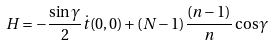Convert formula to latex. <formula><loc_0><loc_0><loc_500><loc_500>H = - \frac { \sin \gamma } { 2 } \dot { t } ( 0 , 0 ) + ( N - 1 ) \frac { ( n - 1 ) } { n } \cos \gamma</formula> 